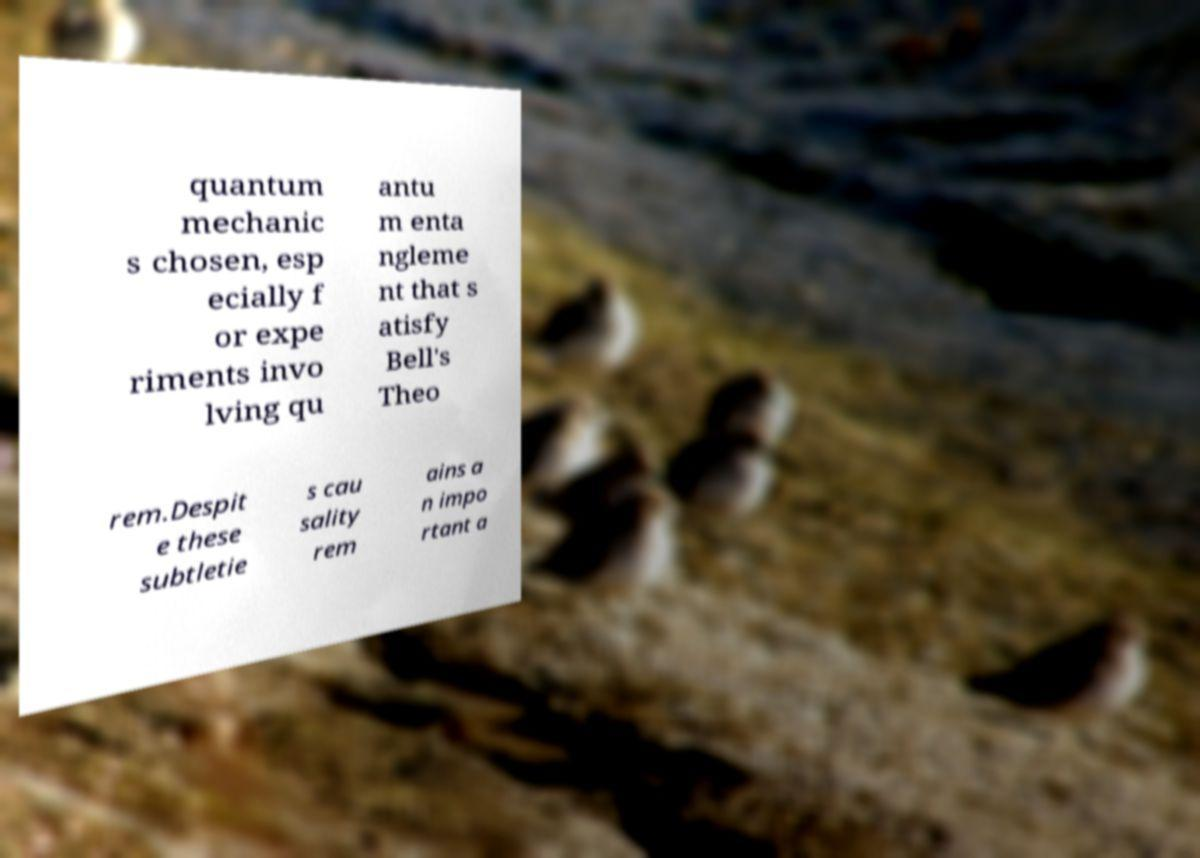There's text embedded in this image that I need extracted. Can you transcribe it verbatim? quantum mechanic s chosen, esp ecially f or expe riments invo lving qu antu m enta ngleme nt that s atisfy Bell's Theo rem.Despit e these subtletie s cau sality rem ains a n impo rtant a 